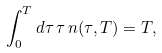<formula> <loc_0><loc_0><loc_500><loc_500>\int _ { 0 } ^ { T } d \tau \, \tau \, n ( \tau , T ) = T ,</formula> 